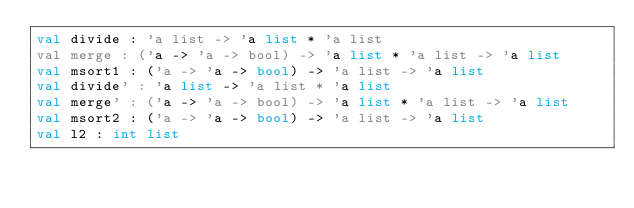<code> <loc_0><loc_0><loc_500><loc_500><_OCaml_>val divide : 'a list -> 'a list * 'a list
val merge : ('a -> 'a -> bool) -> 'a list * 'a list -> 'a list
val msort1 : ('a -> 'a -> bool) -> 'a list -> 'a list
val divide' : 'a list -> 'a list * 'a list
val merge' : ('a -> 'a -> bool) -> 'a list * 'a list -> 'a list
val msort2 : ('a -> 'a -> bool) -> 'a list -> 'a list
val l2 : int list
</code> 